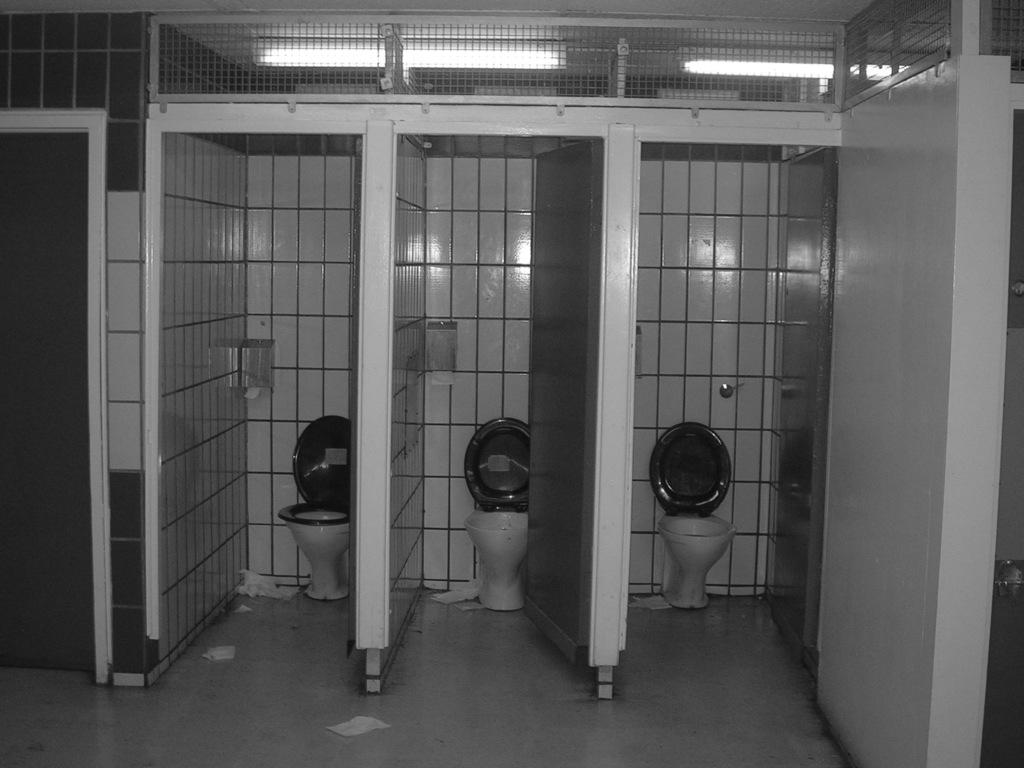What type of room is depicted in the image? The image shows an inner view of a restroom. What can be found in a restroom that is visible in the image? There are toilet seats in the image. Are there any doors in the restroom? Yes, there are doors in the image. What type of tin can be seen hanging on the wall in the image? There is no tin present in the image. How many parcels are visible on the floor in the image? There are no parcels visible in the image. 